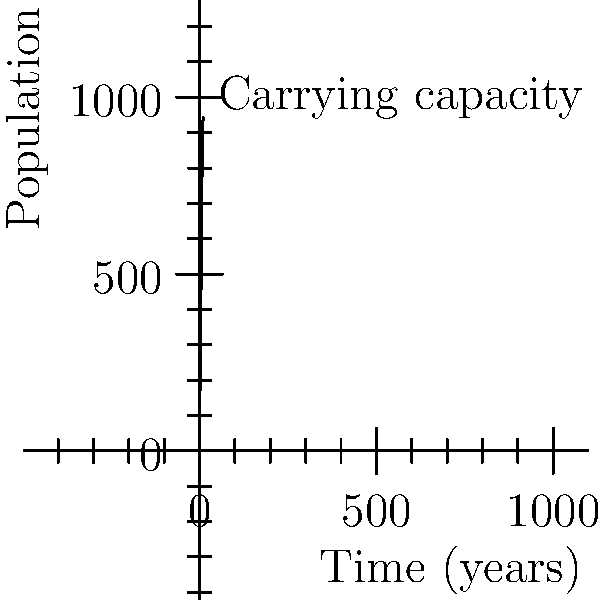A population of deer in a national park follows a logistic growth model. The initial population is 100, and the carrying capacity is 1000. The population at time $t$ (in years) is given by the function:

$$ P(t) = \frac{1000}{1 + 9e^{-0.5t}} $$

What is the growth rate $r$ of this population? To find the growth rate $r$, we need to compare the given function with the standard form of the logistic growth model:

$$ P(t) = \frac{K}{1 + (\frac{K}{P_0} - 1)e^{-rt}} $$

Where:
- $K$ is the carrying capacity
- $P_0$ is the initial population
- $r$ is the growth rate

Step 1: Identify the known values
- $K = 1000$ (carrying capacity)
- $P_0 = 100$ (initial population)

Step 2: Compare the given function with the standard form
$$ \frac{1000}{1 + 9e^{-0.5t}} = \frac{1000}{1 + (\frac{1000}{100} - 1)e^{-rt}} $$

Step 3: Simplify the right side of the equation
$$ \frac{1000}{1 + (\frac{1000}{100} - 1)e^{-rt}} = \frac{1000}{1 + 9e^{-rt}} $$

Step 4: Compare the exponents
$$ -0.5t = -rt $$

Step 5: Solve for $r$
$$ r = 0.5 $$

Therefore, the growth rate $r$ of this population is 0.5.
Answer: $r = 0.5$ 